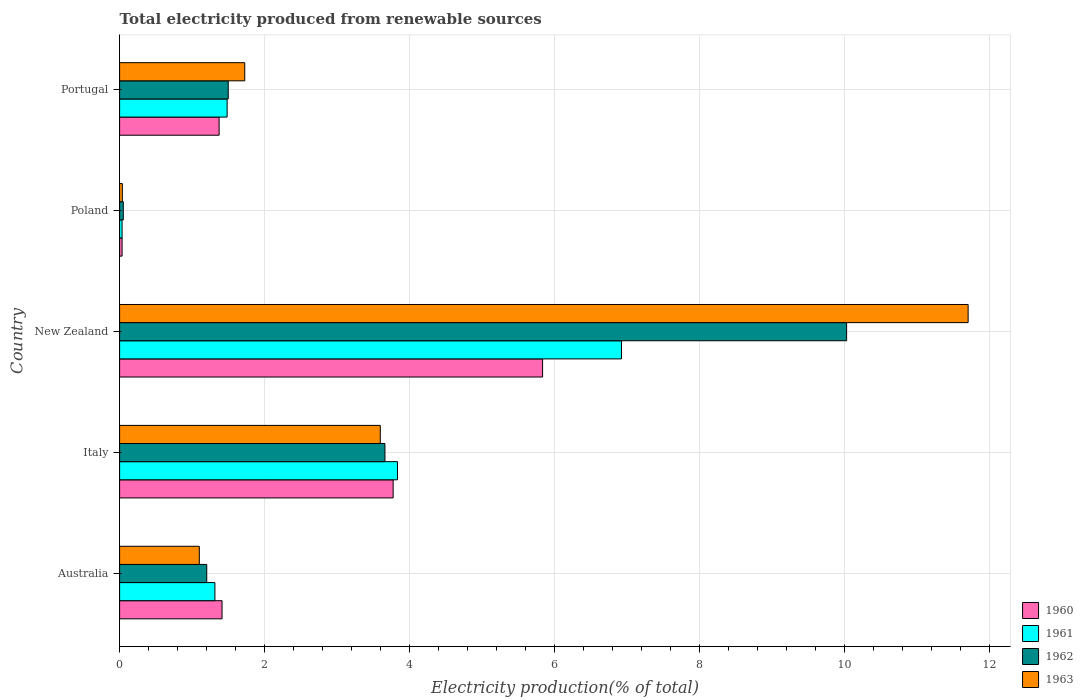How many different coloured bars are there?
Offer a terse response. 4. What is the label of the 4th group of bars from the top?
Offer a terse response. Italy. What is the total electricity produced in 1963 in Portugal?
Make the answer very short. 1.73. Across all countries, what is the maximum total electricity produced in 1961?
Give a very brief answer. 6.92. Across all countries, what is the minimum total electricity produced in 1962?
Your response must be concise. 0.05. In which country was the total electricity produced in 1963 maximum?
Your answer should be very brief. New Zealand. What is the total total electricity produced in 1961 in the graph?
Give a very brief answer. 13.58. What is the difference between the total electricity produced in 1963 in Australia and that in Poland?
Offer a terse response. 1.06. What is the difference between the total electricity produced in 1960 in Poland and the total electricity produced in 1962 in Australia?
Make the answer very short. -1.17. What is the average total electricity produced in 1962 per country?
Make the answer very short. 3.29. What is the difference between the total electricity produced in 1962 and total electricity produced in 1961 in Italy?
Your response must be concise. -0.17. What is the ratio of the total electricity produced in 1963 in Australia to that in New Zealand?
Make the answer very short. 0.09. Is the difference between the total electricity produced in 1962 in Australia and Poland greater than the difference between the total electricity produced in 1961 in Australia and Poland?
Your answer should be compact. No. What is the difference between the highest and the second highest total electricity produced in 1960?
Keep it short and to the point. 2.06. What is the difference between the highest and the lowest total electricity produced in 1961?
Provide a succinct answer. 6.89. What does the 1st bar from the top in New Zealand represents?
Provide a succinct answer. 1963. What does the 4th bar from the bottom in New Zealand represents?
Your answer should be very brief. 1963. How many bars are there?
Offer a terse response. 20. How many countries are there in the graph?
Offer a terse response. 5. Are the values on the major ticks of X-axis written in scientific E-notation?
Your answer should be compact. No. Does the graph contain any zero values?
Provide a succinct answer. No. Does the graph contain grids?
Your response must be concise. Yes. How are the legend labels stacked?
Ensure brevity in your answer.  Vertical. What is the title of the graph?
Your answer should be compact. Total electricity produced from renewable sources. Does "1963" appear as one of the legend labels in the graph?
Ensure brevity in your answer.  Yes. What is the label or title of the Y-axis?
Your answer should be very brief. Country. What is the Electricity production(% of total) in 1960 in Australia?
Make the answer very short. 1.41. What is the Electricity production(% of total) of 1961 in Australia?
Your answer should be very brief. 1.31. What is the Electricity production(% of total) in 1962 in Australia?
Your answer should be compact. 1.2. What is the Electricity production(% of total) of 1963 in Australia?
Ensure brevity in your answer.  1.1. What is the Electricity production(% of total) of 1960 in Italy?
Provide a succinct answer. 3.77. What is the Electricity production(% of total) of 1961 in Italy?
Make the answer very short. 3.83. What is the Electricity production(% of total) of 1962 in Italy?
Provide a succinct answer. 3.66. What is the Electricity production(% of total) of 1963 in Italy?
Keep it short and to the point. 3.59. What is the Electricity production(% of total) in 1960 in New Zealand?
Your answer should be compact. 5.83. What is the Electricity production(% of total) in 1961 in New Zealand?
Give a very brief answer. 6.92. What is the Electricity production(% of total) in 1962 in New Zealand?
Provide a short and direct response. 10.02. What is the Electricity production(% of total) in 1963 in New Zealand?
Ensure brevity in your answer.  11.7. What is the Electricity production(% of total) in 1960 in Poland?
Ensure brevity in your answer.  0.03. What is the Electricity production(% of total) in 1961 in Poland?
Offer a terse response. 0.03. What is the Electricity production(% of total) in 1962 in Poland?
Give a very brief answer. 0.05. What is the Electricity production(% of total) in 1963 in Poland?
Your answer should be compact. 0.04. What is the Electricity production(% of total) of 1960 in Portugal?
Provide a short and direct response. 1.37. What is the Electricity production(% of total) in 1961 in Portugal?
Keep it short and to the point. 1.48. What is the Electricity production(% of total) of 1962 in Portugal?
Provide a succinct answer. 1.5. What is the Electricity production(% of total) of 1963 in Portugal?
Provide a short and direct response. 1.73. Across all countries, what is the maximum Electricity production(% of total) in 1960?
Provide a short and direct response. 5.83. Across all countries, what is the maximum Electricity production(% of total) of 1961?
Offer a very short reply. 6.92. Across all countries, what is the maximum Electricity production(% of total) of 1962?
Make the answer very short. 10.02. Across all countries, what is the maximum Electricity production(% of total) in 1963?
Keep it short and to the point. 11.7. Across all countries, what is the minimum Electricity production(% of total) of 1960?
Offer a very short reply. 0.03. Across all countries, what is the minimum Electricity production(% of total) of 1961?
Give a very brief answer. 0.03. Across all countries, what is the minimum Electricity production(% of total) in 1962?
Provide a short and direct response. 0.05. Across all countries, what is the minimum Electricity production(% of total) in 1963?
Offer a very short reply. 0.04. What is the total Electricity production(% of total) of 1960 in the graph?
Offer a very short reply. 12.42. What is the total Electricity production(% of total) of 1961 in the graph?
Your answer should be very brief. 13.58. What is the total Electricity production(% of total) in 1962 in the graph?
Your answer should be very brief. 16.43. What is the total Electricity production(% of total) of 1963 in the graph?
Your answer should be compact. 18.16. What is the difference between the Electricity production(% of total) of 1960 in Australia and that in Italy?
Offer a very short reply. -2.36. What is the difference between the Electricity production(% of total) in 1961 in Australia and that in Italy?
Your answer should be compact. -2.52. What is the difference between the Electricity production(% of total) of 1962 in Australia and that in Italy?
Provide a succinct answer. -2.46. What is the difference between the Electricity production(% of total) in 1963 in Australia and that in Italy?
Your answer should be compact. -2.5. What is the difference between the Electricity production(% of total) of 1960 in Australia and that in New Zealand?
Your answer should be very brief. -4.42. What is the difference between the Electricity production(% of total) of 1961 in Australia and that in New Zealand?
Offer a terse response. -5.61. What is the difference between the Electricity production(% of total) in 1962 in Australia and that in New Zealand?
Ensure brevity in your answer.  -8.82. What is the difference between the Electricity production(% of total) of 1963 in Australia and that in New Zealand?
Your answer should be very brief. -10.6. What is the difference between the Electricity production(% of total) of 1960 in Australia and that in Poland?
Your answer should be very brief. 1.38. What is the difference between the Electricity production(% of total) in 1961 in Australia and that in Poland?
Make the answer very short. 1.28. What is the difference between the Electricity production(% of total) of 1962 in Australia and that in Poland?
Keep it short and to the point. 1.15. What is the difference between the Electricity production(% of total) in 1963 in Australia and that in Poland?
Your answer should be very brief. 1.06. What is the difference between the Electricity production(% of total) of 1960 in Australia and that in Portugal?
Provide a short and direct response. 0.04. What is the difference between the Electricity production(% of total) of 1961 in Australia and that in Portugal?
Your answer should be very brief. -0.17. What is the difference between the Electricity production(% of total) in 1962 in Australia and that in Portugal?
Provide a succinct answer. -0.3. What is the difference between the Electricity production(% of total) of 1963 in Australia and that in Portugal?
Keep it short and to the point. -0.63. What is the difference between the Electricity production(% of total) in 1960 in Italy and that in New Zealand?
Ensure brevity in your answer.  -2.06. What is the difference between the Electricity production(% of total) in 1961 in Italy and that in New Zealand?
Offer a very short reply. -3.09. What is the difference between the Electricity production(% of total) of 1962 in Italy and that in New Zealand?
Make the answer very short. -6.37. What is the difference between the Electricity production(% of total) in 1963 in Italy and that in New Zealand?
Keep it short and to the point. -8.11. What is the difference between the Electricity production(% of total) of 1960 in Italy and that in Poland?
Your answer should be very brief. 3.74. What is the difference between the Electricity production(% of total) in 1961 in Italy and that in Poland?
Keep it short and to the point. 3.8. What is the difference between the Electricity production(% of total) in 1962 in Italy and that in Poland?
Keep it short and to the point. 3.61. What is the difference between the Electricity production(% of total) in 1963 in Italy and that in Poland?
Make the answer very short. 3.56. What is the difference between the Electricity production(% of total) in 1960 in Italy and that in Portugal?
Your answer should be compact. 2.4. What is the difference between the Electricity production(% of total) of 1961 in Italy and that in Portugal?
Provide a succinct answer. 2.35. What is the difference between the Electricity production(% of total) in 1962 in Italy and that in Portugal?
Provide a short and direct response. 2.16. What is the difference between the Electricity production(% of total) in 1963 in Italy and that in Portugal?
Your response must be concise. 1.87. What is the difference between the Electricity production(% of total) of 1960 in New Zealand and that in Poland?
Your response must be concise. 5.8. What is the difference between the Electricity production(% of total) in 1961 in New Zealand and that in Poland?
Ensure brevity in your answer.  6.89. What is the difference between the Electricity production(% of total) in 1962 in New Zealand and that in Poland?
Your answer should be very brief. 9.97. What is the difference between the Electricity production(% of total) in 1963 in New Zealand and that in Poland?
Give a very brief answer. 11.66. What is the difference between the Electricity production(% of total) in 1960 in New Zealand and that in Portugal?
Make the answer very short. 4.46. What is the difference between the Electricity production(% of total) of 1961 in New Zealand and that in Portugal?
Make the answer very short. 5.44. What is the difference between the Electricity production(% of total) of 1962 in New Zealand and that in Portugal?
Give a very brief answer. 8.53. What is the difference between the Electricity production(% of total) of 1963 in New Zealand and that in Portugal?
Provide a short and direct response. 9.97. What is the difference between the Electricity production(% of total) in 1960 in Poland and that in Portugal?
Ensure brevity in your answer.  -1.34. What is the difference between the Electricity production(% of total) of 1961 in Poland and that in Portugal?
Provide a short and direct response. -1.45. What is the difference between the Electricity production(% of total) of 1962 in Poland and that in Portugal?
Provide a short and direct response. -1.45. What is the difference between the Electricity production(% of total) of 1963 in Poland and that in Portugal?
Your answer should be very brief. -1.69. What is the difference between the Electricity production(% of total) of 1960 in Australia and the Electricity production(% of total) of 1961 in Italy?
Offer a very short reply. -2.42. What is the difference between the Electricity production(% of total) of 1960 in Australia and the Electricity production(% of total) of 1962 in Italy?
Keep it short and to the point. -2.25. What is the difference between the Electricity production(% of total) in 1960 in Australia and the Electricity production(% of total) in 1963 in Italy?
Ensure brevity in your answer.  -2.18. What is the difference between the Electricity production(% of total) of 1961 in Australia and the Electricity production(% of total) of 1962 in Italy?
Your answer should be very brief. -2.34. What is the difference between the Electricity production(% of total) of 1961 in Australia and the Electricity production(% of total) of 1963 in Italy?
Offer a terse response. -2.28. What is the difference between the Electricity production(% of total) of 1962 in Australia and the Electricity production(% of total) of 1963 in Italy?
Ensure brevity in your answer.  -2.39. What is the difference between the Electricity production(% of total) of 1960 in Australia and the Electricity production(% of total) of 1961 in New Zealand?
Your answer should be very brief. -5.51. What is the difference between the Electricity production(% of total) in 1960 in Australia and the Electricity production(% of total) in 1962 in New Zealand?
Provide a short and direct response. -8.61. What is the difference between the Electricity production(% of total) of 1960 in Australia and the Electricity production(% of total) of 1963 in New Zealand?
Give a very brief answer. -10.29. What is the difference between the Electricity production(% of total) of 1961 in Australia and the Electricity production(% of total) of 1962 in New Zealand?
Your response must be concise. -8.71. What is the difference between the Electricity production(% of total) in 1961 in Australia and the Electricity production(% of total) in 1963 in New Zealand?
Your answer should be compact. -10.39. What is the difference between the Electricity production(% of total) in 1962 in Australia and the Electricity production(% of total) in 1963 in New Zealand?
Make the answer very short. -10.5. What is the difference between the Electricity production(% of total) in 1960 in Australia and the Electricity production(% of total) in 1961 in Poland?
Offer a very short reply. 1.38. What is the difference between the Electricity production(% of total) of 1960 in Australia and the Electricity production(% of total) of 1962 in Poland?
Your response must be concise. 1.36. What is the difference between the Electricity production(% of total) in 1960 in Australia and the Electricity production(% of total) in 1963 in Poland?
Make the answer very short. 1.37. What is the difference between the Electricity production(% of total) in 1961 in Australia and the Electricity production(% of total) in 1962 in Poland?
Offer a terse response. 1.26. What is the difference between the Electricity production(% of total) of 1961 in Australia and the Electricity production(% of total) of 1963 in Poland?
Offer a very short reply. 1.28. What is the difference between the Electricity production(% of total) in 1962 in Australia and the Electricity production(% of total) in 1963 in Poland?
Keep it short and to the point. 1.16. What is the difference between the Electricity production(% of total) in 1960 in Australia and the Electricity production(% of total) in 1961 in Portugal?
Your answer should be very brief. -0.07. What is the difference between the Electricity production(% of total) in 1960 in Australia and the Electricity production(% of total) in 1962 in Portugal?
Offer a very short reply. -0.09. What is the difference between the Electricity production(% of total) of 1960 in Australia and the Electricity production(% of total) of 1963 in Portugal?
Your response must be concise. -0.31. What is the difference between the Electricity production(% of total) in 1961 in Australia and the Electricity production(% of total) in 1962 in Portugal?
Make the answer very short. -0.18. What is the difference between the Electricity production(% of total) in 1961 in Australia and the Electricity production(% of total) in 1963 in Portugal?
Provide a short and direct response. -0.41. What is the difference between the Electricity production(% of total) of 1962 in Australia and the Electricity production(% of total) of 1963 in Portugal?
Ensure brevity in your answer.  -0.52. What is the difference between the Electricity production(% of total) in 1960 in Italy and the Electricity production(% of total) in 1961 in New Zealand?
Keep it short and to the point. -3.15. What is the difference between the Electricity production(% of total) in 1960 in Italy and the Electricity production(% of total) in 1962 in New Zealand?
Offer a very short reply. -6.25. What is the difference between the Electricity production(% of total) of 1960 in Italy and the Electricity production(% of total) of 1963 in New Zealand?
Offer a terse response. -7.93. What is the difference between the Electricity production(% of total) of 1961 in Italy and the Electricity production(% of total) of 1962 in New Zealand?
Keep it short and to the point. -6.19. What is the difference between the Electricity production(% of total) in 1961 in Italy and the Electricity production(% of total) in 1963 in New Zealand?
Offer a terse response. -7.87. What is the difference between the Electricity production(% of total) of 1962 in Italy and the Electricity production(% of total) of 1963 in New Zealand?
Offer a very short reply. -8.04. What is the difference between the Electricity production(% of total) of 1960 in Italy and the Electricity production(% of total) of 1961 in Poland?
Keep it short and to the point. 3.74. What is the difference between the Electricity production(% of total) of 1960 in Italy and the Electricity production(% of total) of 1962 in Poland?
Your answer should be compact. 3.72. What is the difference between the Electricity production(% of total) in 1960 in Italy and the Electricity production(% of total) in 1963 in Poland?
Ensure brevity in your answer.  3.73. What is the difference between the Electricity production(% of total) in 1961 in Italy and the Electricity production(% of total) in 1962 in Poland?
Your answer should be very brief. 3.78. What is the difference between the Electricity production(% of total) of 1961 in Italy and the Electricity production(% of total) of 1963 in Poland?
Give a very brief answer. 3.79. What is the difference between the Electricity production(% of total) in 1962 in Italy and the Electricity production(% of total) in 1963 in Poland?
Make the answer very short. 3.62. What is the difference between the Electricity production(% of total) of 1960 in Italy and the Electricity production(% of total) of 1961 in Portugal?
Your response must be concise. 2.29. What is the difference between the Electricity production(% of total) in 1960 in Italy and the Electricity production(% of total) in 1962 in Portugal?
Your answer should be compact. 2.27. What is the difference between the Electricity production(% of total) in 1960 in Italy and the Electricity production(% of total) in 1963 in Portugal?
Your answer should be compact. 2.05. What is the difference between the Electricity production(% of total) of 1961 in Italy and the Electricity production(% of total) of 1962 in Portugal?
Your response must be concise. 2.33. What is the difference between the Electricity production(% of total) of 1961 in Italy and the Electricity production(% of total) of 1963 in Portugal?
Ensure brevity in your answer.  2.11. What is the difference between the Electricity production(% of total) in 1962 in Italy and the Electricity production(% of total) in 1963 in Portugal?
Provide a succinct answer. 1.93. What is the difference between the Electricity production(% of total) of 1960 in New Zealand and the Electricity production(% of total) of 1961 in Poland?
Provide a short and direct response. 5.8. What is the difference between the Electricity production(% of total) in 1960 in New Zealand and the Electricity production(% of total) in 1962 in Poland?
Offer a terse response. 5.78. What is the difference between the Electricity production(% of total) of 1960 in New Zealand and the Electricity production(% of total) of 1963 in Poland?
Ensure brevity in your answer.  5.79. What is the difference between the Electricity production(% of total) of 1961 in New Zealand and the Electricity production(% of total) of 1962 in Poland?
Offer a terse response. 6.87. What is the difference between the Electricity production(% of total) of 1961 in New Zealand and the Electricity production(% of total) of 1963 in Poland?
Ensure brevity in your answer.  6.88. What is the difference between the Electricity production(% of total) in 1962 in New Zealand and the Electricity production(% of total) in 1963 in Poland?
Your answer should be compact. 9.99. What is the difference between the Electricity production(% of total) of 1960 in New Zealand and the Electricity production(% of total) of 1961 in Portugal?
Ensure brevity in your answer.  4.35. What is the difference between the Electricity production(% of total) in 1960 in New Zealand and the Electricity production(% of total) in 1962 in Portugal?
Ensure brevity in your answer.  4.33. What is the difference between the Electricity production(% of total) of 1960 in New Zealand and the Electricity production(% of total) of 1963 in Portugal?
Your answer should be compact. 4.11. What is the difference between the Electricity production(% of total) in 1961 in New Zealand and the Electricity production(% of total) in 1962 in Portugal?
Provide a short and direct response. 5.42. What is the difference between the Electricity production(% of total) of 1961 in New Zealand and the Electricity production(% of total) of 1963 in Portugal?
Your answer should be compact. 5.19. What is the difference between the Electricity production(% of total) of 1962 in New Zealand and the Electricity production(% of total) of 1963 in Portugal?
Offer a very short reply. 8.3. What is the difference between the Electricity production(% of total) of 1960 in Poland and the Electricity production(% of total) of 1961 in Portugal?
Your answer should be very brief. -1.45. What is the difference between the Electricity production(% of total) in 1960 in Poland and the Electricity production(% of total) in 1962 in Portugal?
Provide a short and direct response. -1.46. What is the difference between the Electricity production(% of total) in 1960 in Poland and the Electricity production(% of total) in 1963 in Portugal?
Offer a terse response. -1.69. What is the difference between the Electricity production(% of total) of 1961 in Poland and the Electricity production(% of total) of 1962 in Portugal?
Ensure brevity in your answer.  -1.46. What is the difference between the Electricity production(% of total) of 1961 in Poland and the Electricity production(% of total) of 1963 in Portugal?
Your response must be concise. -1.69. What is the difference between the Electricity production(% of total) in 1962 in Poland and the Electricity production(% of total) in 1963 in Portugal?
Make the answer very short. -1.67. What is the average Electricity production(% of total) in 1960 per country?
Your response must be concise. 2.48. What is the average Electricity production(% of total) of 1961 per country?
Make the answer very short. 2.72. What is the average Electricity production(% of total) in 1962 per country?
Provide a succinct answer. 3.29. What is the average Electricity production(% of total) in 1963 per country?
Offer a very short reply. 3.63. What is the difference between the Electricity production(% of total) of 1960 and Electricity production(% of total) of 1961 in Australia?
Your response must be concise. 0.1. What is the difference between the Electricity production(% of total) in 1960 and Electricity production(% of total) in 1962 in Australia?
Make the answer very short. 0.21. What is the difference between the Electricity production(% of total) in 1960 and Electricity production(% of total) in 1963 in Australia?
Provide a short and direct response. 0.31. What is the difference between the Electricity production(% of total) of 1961 and Electricity production(% of total) of 1962 in Australia?
Give a very brief answer. 0.11. What is the difference between the Electricity production(% of total) of 1961 and Electricity production(% of total) of 1963 in Australia?
Keep it short and to the point. 0.21. What is the difference between the Electricity production(% of total) in 1962 and Electricity production(% of total) in 1963 in Australia?
Your answer should be compact. 0.1. What is the difference between the Electricity production(% of total) of 1960 and Electricity production(% of total) of 1961 in Italy?
Ensure brevity in your answer.  -0.06. What is the difference between the Electricity production(% of total) in 1960 and Electricity production(% of total) in 1962 in Italy?
Ensure brevity in your answer.  0.11. What is the difference between the Electricity production(% of total) in 1960 and Electricity production(% of total) in 1963 in Italy?
Keep it short and to the point. 0.18. What is the difference between the Electricity production(% of total) of 1961 and Electricity production(% of total) of 1962 in Italy?
Offer a very short reply. 0.17. What is the difference between the Electricity production(% of total) in 1961 and Electricity production(% of total) in 1963 in Italy?
Your answer should be very brief. 0.24. What is the difference between the Electricity production(% of total) of 1962 and Electricity production(% of total) of 1963 in Italy?
Your answer should be compact. 0.06. What is the difference between the Electricity production(% of total) of 1960 and Electricity production(% of total) of 1961 in New Zealand?
Provide a short and direct response. -1.09. What is the difference between the Electricity production(% of total) in 1960 and Electricity production(% of total) in 1962 in New Zealand?
Offer a terse response. -4.19. What is the difference between the Electricity production(% of total) in 1960 and Electricity production(% of total) in 1963 in New Zealand?
Offer a very short reply. -5.87. What is the difference between the Electricity production(% of total) of 1961 and Electricity production(% of total) of 1962 in New Zealand?
Keep it short and to the point. -3.1. What is the difference between the Electricity production(% of total) in 1961 and Electricity production(% of total) in 1963 in New Zealand?
Your answer should be very brief. -4.78. What is the difference between the Electricity production(% of total) in 1962 and Electricity production(% of total) in 1963 in New Zealand?
Keep it short and to the point. -1.68. What is the difference between the Electricity production(% of total) in 1960 and Electricity production(% of total) in 1962 in Poland?
Offer a very short reply. -0.02. What is the difference between the Electricity production(% of total) in 1960 and Electricity production(% of total) in 1963 in Poland?
Provide a succinct answer. -0. What is the difference between the Electricity production(% of total) of 1961 and Electricity production(% of total) of 1962 in Poland?
Ensure brevity in your answer.  -0.02. What is the difference between the Electricity production(% of total) in 1961 and Electricity production(% of total) in 1963 in Poland?
Offer a very short reply. -0. What is the difference between the Electricity production(% of total) in 1962 and Electricity production(% of total) in 1963 in Poland?
Make the answer very short. 0.01. What is the difference between the Electricity production(% of total) in 1960 and Electricity production(% of total) in 1961 in Portugal?
Keep it short and to the point. -0.11. What is the difference between the Electricity production(% of total) of 1960 and Electricity production(% of total) of 1962 in Portugal?
Give a very brief answer. -0.13. What is the difference between the Electricity production(% of total) in 1960 and Electricity production(% of total) in 1963 in Portugal?
Your answer should be very brief. -0.35. What is the difference between the Electricity production(% of total) in 1961 and Electricity production(% of total) in 1962 in Portugal?
Offer a very short reply. -0.02. What is the difference between the Electricity production(% of total) in 1961 and Electricity production(% of total) in 1963 in Portugal?
Provide a short and direct response. -0.24. What is the difference between the Electricity production(% of total) of 1962 and Electricity production(% of total) of 1963 in Portugal?
Your response must be concise. -0.23. What is the ratio of the Electricity production(% of total) in 1960 in Australia to that in Italy?
Your response must be concise. 0.37. What is the ratio of the Electricity production(% of total) of 1961 in Australia to that in Italy?
Your answer should be compact. 0.34. What is the ratio of the Electricity production(% of total) in 1962 in Australia to that in Italy?
Make the answer very short. 0.33. What is the ratio of the Electricity production(% of total) in 1963 in Australia to that in Italy?
Your response must be concise. 0.31. What is the ratio of the Electricity production(% of total) in 1960 in Australia to that in New Zealand?
Your response must be concise. 0.24. What is the ratio of the Electricity production(% of total) of 1961 in Australia to that in New Zealand?
Your answer should be compact. 0.19. What is the ratio of the Electricity production(% of total) of 1962 in Australia to that in New Zealand?
Your answer should be compact. 0.12. What is the ratio of the Electricity production(% of total) in 1963 in Australia to that in New Zealand?
Provide a succinct answer. 0.09. What is the ratio of the Electricity production(% of total) of 1960 in Australia to that in Poland?
Offer a terse response. 41.37. What is the ratio of the Electricity production(% of total) in 1961 in Australia to that in Poland?
Your answer should be very brief. 38.51. What is the ratio of the Electricity production(% of total) in 1962 in Australia to that in Poland?
Keep it short and to the point. 23.61. What is the ratio of the Electricity production(% of total) of 1963 in Australia to that in Poland?
Provide a succinct answer. 29. What is the ratio of the Electricity production(% of total) in 1960 in Australia to that in Portugal?
Keep it short and to the point. 1.03. What is the ratio of the Electricity production(% of total) in 1961 in Australia to that in Portugal?
Provide a short and direct response. 0.89. What is the ratio of the Electricity production(% of total) in 1962 in Australia to that in Portugal?
Ensure brevity in your answer.  0.8. What is the ratio of the Electricity production(% of total) in 1963 in Australia to that in Portugal?
Provide a succinct answer. 0.64. What is the ratio of the Electricity production(% of total) in 1960 in Italy to that in New Zealand?
Ensure brevity in your answer.  0.65. What is the ratio of the Electricity production(% of total) of 1961 in Italy to that in New Zealand?
Provide a succinct answer. 0.55. What is the ratio of the Electricity production(% of total) in 1962 in Italy to that in New Zealand?
Your response must be concise. 0.36. What is the ratio of the Electricity production(% of total) in 1963 in Italy to that in New Zealand?
Ensure brevity in your answer.  0.31. What is the ratio of the Electricity production(% of total) in 1960 in Italy to that in Poland?
Provide a short and direct response. 110.45. What is the ratio of the Electricity production(% of total) in 1961 in Italy to that in Poland?
Keep it short and to the point. 112.3. What is the ratio of the Electricity production(% of total) of 1962 in Italy to that in Poland?
Provide a short and direct response. 71.88. What is the ratio of the Electricity production(% of total) of 1963 in Italy to that in Poland?
Make the answer very short. 94.84. What is the ratio of the Electricity production(% of total) in 1960 in Italy to that in Portugal?
Make the answer very short. 2.75. What is the ratio of the Electricity production(% of total) of 1961 in Italy to that in Portugal?
Your response must be concise. 2.58. What is the ratio of the Electricity production(% of total) of 1962 in Italy to that in Portugal?
Give a very brief answer. 2.44. What is the ratio of the Electricity production(% of total) in 1963 in Italy to that in Portugal?
Offer a very short reply. 2.08. What is the ratio of the Electricity production(% of total) of 1960 in New Zealand to that in Poland?
Provide a succinct answer. 170.79. What is the ratio of the Electricity production(% of total) of 1961 in New Zealand to that in Poland?
Give a very brief answer. 202.83. What is the ratio of the Electricity production(% of total) in 1962 in New Zealand to that in Poland?
Your response must be concise. 196.95. What is the ratio of the Electricity production(% of total) in 1963 in New Zealand to that in Poland?
Your answer should be very brief. 308.73. What is the ratio of the Electricity production(% of total) of 1960 in New Zealand to that in Portugal?
Offer a terse response. 4.25. What is the ratio of the Electricity production(% of total) of 1961 in New Zealand to that in Portugal?
Provide a succinct answer. 4.67. What is the ratio of the Electricity production(% of total) of 1962 in New Zealand to that in Portugal?
Your answer should be very brief. 6.69. What is the ratio of the Electricity production(% of total) of 1963 in New Zealand to that in Portugal?
Your answer should be very brief. 6.78. What is the ratio of the Electricity production(% of total) of 1960 in Poland to that in Portugal?
Provide a succinct answer. 0.02. What is the ratio of the Electricity production(% of total) in 1961 in Poland to that in Portugal?
Your response must be concise. 0.02. What is the ratio of the Electricity production(% of total) of 1962 in Poland to that in Portugal?
Offer a terse response. 0.03. What is the ratio of the Electricity production(% of total) in 1963 in Poland to that in Portugal?
Offer a very short reply. 0.02. What is the difference between the highest and the second highest Electricity production(% of total) in 1960?
Give a very brief answer. 2.06. What is the difference between the highest and the second highest Electricity production(% of total) in 1961?
Give a very brief answer. 3.09. What is the difference between the highest and the second highest Electricity production(% of total) in 1962?
Offer a terse response. 6.37. What is the difference between the highest and the second highest Electricity production(% of total) in 1963?
Your answer should be compact. 8.11. What is the difference between the highest and the lowest Electricity production(% of total) of 1960?
Make the answer very short. 5.8. What is the difference between the highest and the lowest Electricity production(% of total) of 1961?
Give a very brief answer. 6.89. What is the difference between the highest and the lowest Electricity production(% of total) in 1962?
Your answer should be compact. 9.97. What is the difference between the highest and the lowest Electricity production(% of total) in 1963?
Your answer should be compact. 11.66. 